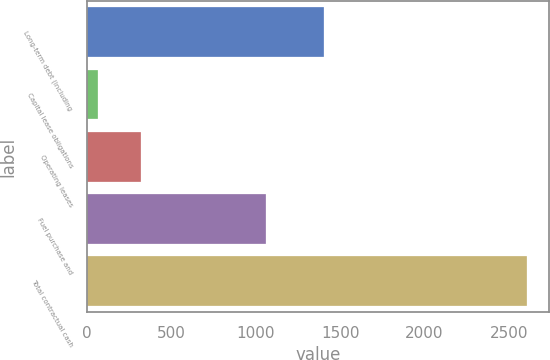<chart> <loc_0><loc_0><loc_500><loc_500><bar_chart><fcel>Long-term debt (including<fcel>Capital lease obligations<fcel>Operating leases<fcel>Fuel purchase and<fcel>Total contractual cash<nl><fcel>1407<fcel>66<fcel>319.9<fcel>1059<fcel>2605<nl></chart> 